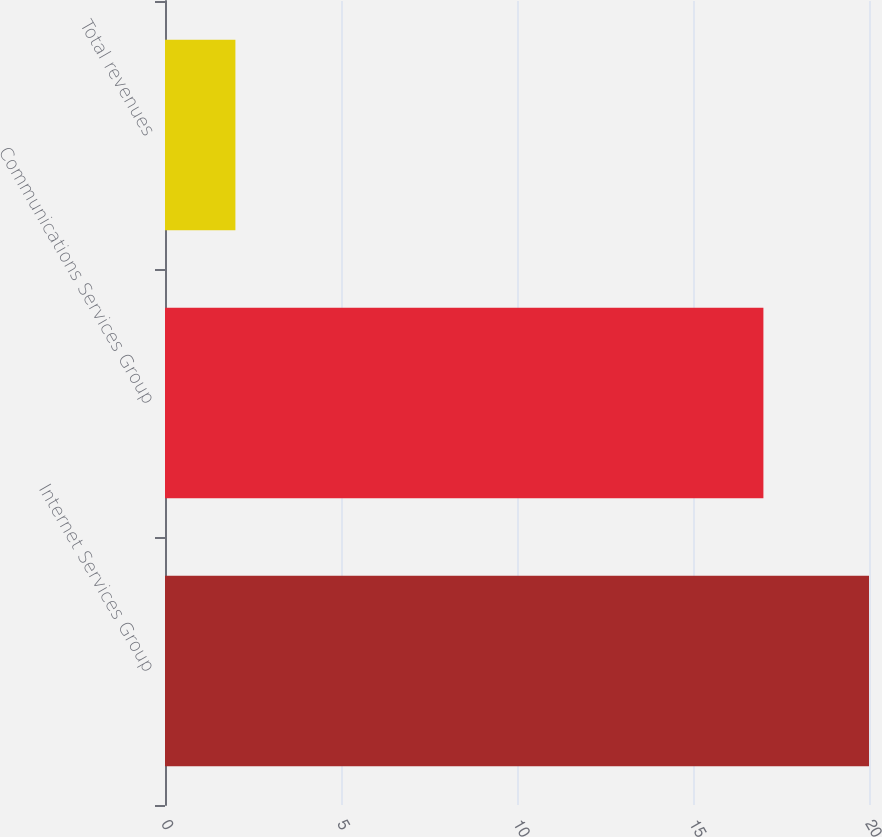Convert chart to OTSL. <chart><loc_0><loc_0><loc_500><loc_500><bar_chart><fcel>Internet Services Group<fcel>Communications Services Group<fcel>Total revenues<nl><fcel>20<fcel>17<fcel>2<nl></chart> 